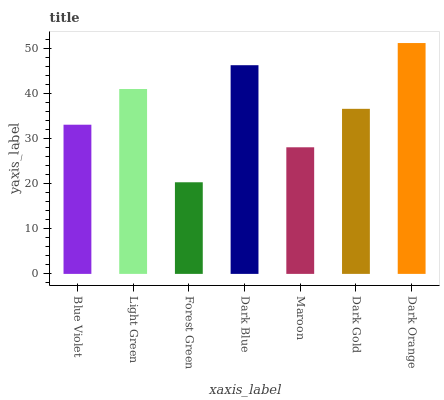Is Forest Green the minimum?
Answer yes or no. Yes. Is Dark Orange the maximum?
Answer yes or no. Yes. Is Light Green the minimum?
Answer yes or no. No. Is Light Green the maximum?
Answer yes or no. No. Is Light Green greater than Blue Violet?
Answer yes or no. Yes. Is Blue Violet less than Light Green?
Answer yes or no. Yes. Is Blue Violet greater than Light Green?
Answer yes or no. No. Is Light Green less than Blue Violet?
Answer yes or no. No. Is Dark Gold the high median?
Answer yes or no. Yes. Is Dark Gold the low median?
Answer yes or no. Yes. Is Light Green the high median?
Answer yes or no. No. Is Dark Blue the low median?
Answer yes or no. No. 